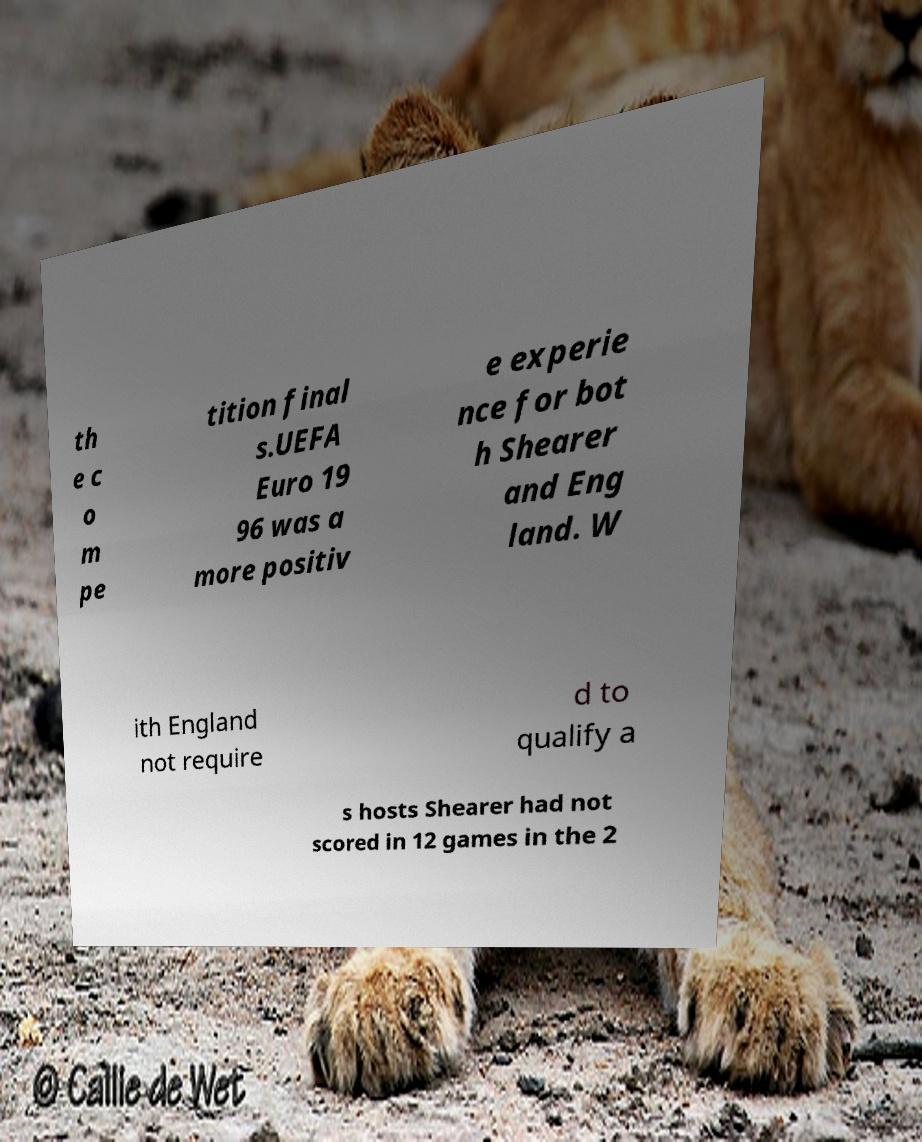Could you extract and type out the text from this image? th e c o m pe tition final s.UEFA Euro 19 96 was a more positiv e experie nce for bot h Shearer and Eng land. W ith England not require d to qualify a s hosts Shearer had not scored in 12 games in the 2 